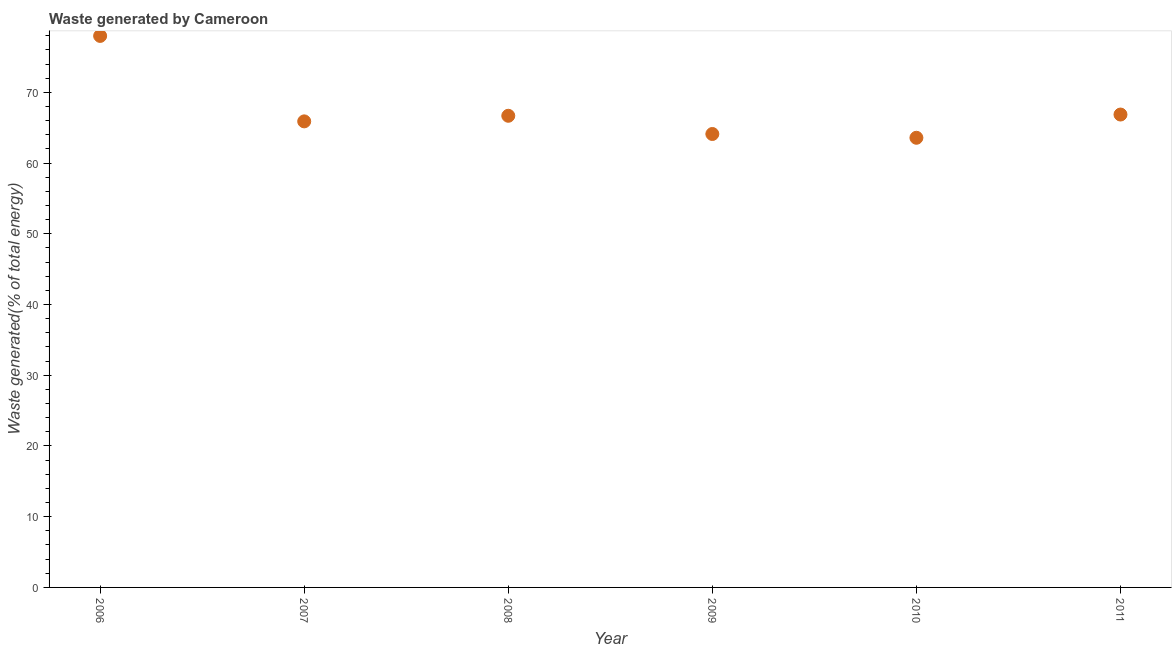What is the amount of waste generated in 2007?
Offer a very short reply. 65.9. Across all years, what is the maximum amount of waste generated?
Make the answer very short. 77.98. Across all years, what is the minimum amount of waste generated?
Your answer should be compact. 63.58. In which year was the amount of waste generated maximum?
Offer a terse response. 2006. What is the sum of the amount of waste generated?
Make the answer very short. 405.12. What is the difference between the amount of waste generated in 2009 and 2011?
Your answer should be compact. -2.75. What is the average amount of waste generated per year?
Your answer should be very brief. 67.52. What is the median amount of waste generated?
Give a very brief answer. 66.29. Do a majority of the years between 2008 and 2011 (inclusive) have amount of waste generated greater than 6 %?
Keep it short and to the point. Yes. What is the ratio of the amount of waste generated in 2008 to that in 2011?
Give a very brief answer. 1. What is the difference between the highest and the second highest amount of waste generated?
Offer a very short reply. 11.12. Is the sum of the amount of waste generated in 2007 and 2010 greater than the maximum amount of waste generated across all years?
Your answer should be compact. Yes. What is the difference between the highest and the lowest amount of waste generated?
Provide a succinct answer. 14.4. How many dotlines are there?
Your answer should be very brief. 1. Does the graph contain grids?
Keep it short and to the point. No. What is the title of the graph?
Ensure brevity in your answer.  Waste generated by Cameroon. What is the label or title of the X-axis?
Your answer should be compact. Year. What is the label or title of the Y-axis?
Ensure brevity in your answer.  Waste generated(% of total energy). What is the Waste generated(% of total energy) in 2006?
Give a very brief answer. 77.98. What is the Waste generated(% of total energy) in 2007?
Your response must be concise. 65.9. What is the Waste generated(% of total energy) in 2008?
Provide a succinct answer. 66.69. What is the Waste generated(% of total energy) in 2009?
Give a very brief answer. 64.11. What is the Waste generated(% of total energy) in 2010?
Provide a succinct answer. 63.58. What is the Waste generated(% of total energy) in 2011?
Make the answer very short. 66.86. What is the difference between the Waste generated(% of total energy) in 2006 and 2007?
Keep it short and to the point. 12.08. What is the difference between the Waste generated(% of total energy) in 2006 and 2008?
Provide a succinct answer. 11.29. What is the difference between the Waste generated(% of total energy) in 2006 and 2009?
Keep it short and to the point. 13.87. What is the difference between the Waste generated(% of total energy) in 2006 and 2010?
Your answer should be compact. 14.4. What is the difference between the Waste generated(% of total energy) in 2006 and 2011?
Your answer should be very brief. 11.12. What is the difference between the Waste generated(% of total energy) in 2007 and 2008?
Offer a terse response. -0.79. What is the difference between the Waste generated(% of total energy) in 2007 and 2009?
Make the answer very short. 1.78. What is the difference between the Waste generated(% of total energy) in 2007 and 2010?
Keep it short and to the point. 2.32. What is the difference between the Waste generated(% of total energy) in 2007 and 2011?
Your answer should be compact. -0.97. What is the difference between the Waste generated(% of total energy) in 2008 and 2009?
Your answer should be compact. 2.58. What is the difference between the Waste generated(% of total energy) in 2008 and 2010?
Your response must be concise. 3.11. What is the difference between the Waste generated(% of total energy) in 2008 and 2011?
Provide a short and direct response. -0.18. What is the difference between the Waste generated(% of total energy) in 2009 and 2010?
Provide a succinct answer. 0.53. What is the difference between the Waste generated(% of total energy) in 2009 and 2011?
Make the answer very short. -2.75. What is the difference between the Waste generated(% of total energy) in 2010 and 2011?
Make the answer very short. -3.29. What is the ratio of the Waste generated(% of total energy) in 2006 to that in 2007?
Your answer should be compact. 1.18. What is the ratio of the Waste generated(% of total energy) in 2006 to that in 2008?
Provide a succinct answer. 1.17. What is the ratio of the Waste generated(% of total energy) in 2006 to that in 2009?
Your answer should be compact. 1.22. What is the ratio of the Waste generated(% of total energy) in 2006 to that in 2010?
Ensure brevity in your answer.  1.23. What is the ratio of the Waste generated(% of total energy) in 2006 to that in 2011?
Give a very brief answer. 1.17. What is the ratio of the Waste generated(% of total energy) in 2007 to that in 2009?
Make the answer very short. 1.03. What is the ratio of the Waste generated(% of total energy) in 2007 to that in 2010?
Your answer should be compact. 1.04. What is the ratio of the Waste generated(% of total energy) in 2007 to that in 2011?
Provide a short and direct response. 0.99. What is the ratio of the Waste generated(% of total energy) in 2008 to that in 2010?
Offer a very short reply. 1.05. What is the ratio of the Waste generated(% of total energy) in 2008 to that in 2011?
Provide a short and direct response. 1. What is the ratio of the Waste generated(% of total energy) in 2009 to that in 2010?
Give a very brief answer. 1.01. What is the ratio of the Waste generated(% of total energy) in 2009 to that in 2011?
Your response must be concise. 0.96. What is the ratio of the Waste generated(% of total energy) in 2010 to that in 2011?
Provide a succinct answer. 0.95. 